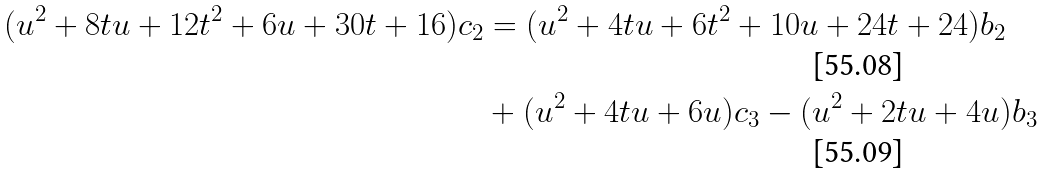<formula> <loc_0><loc_0><loc_500><loc_500>( u ^ { 2 } + 8 t u + 1 2 t ^ { 2 } + 6 u + 3 0 t + 1 6 ) c _ { 2 } & = ( u ^ { 2 } + 4 t u + 6 t ^ { 2 } + 1 0 u + 2 4 t + 2 4 ) b _ { 2 } \\ & + ( u ^ { 2 } + 4 t u + 6 u ) c _ { 3 } - ( u ^ { 2 } + 2 t u + 4 u ) b _ { 3 }</formula> 